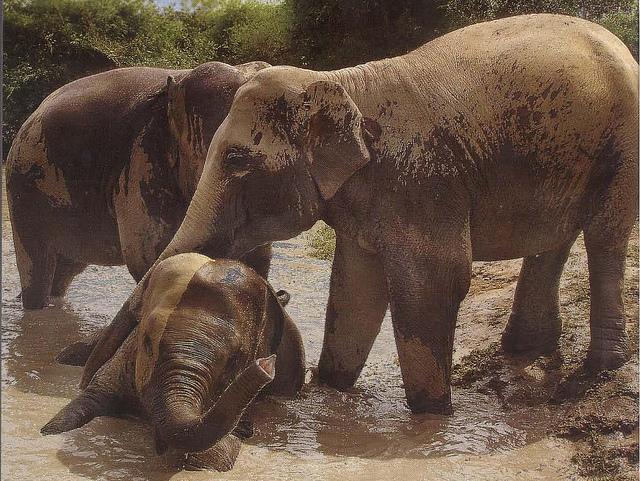Which deity looks like these animals? ganesha 